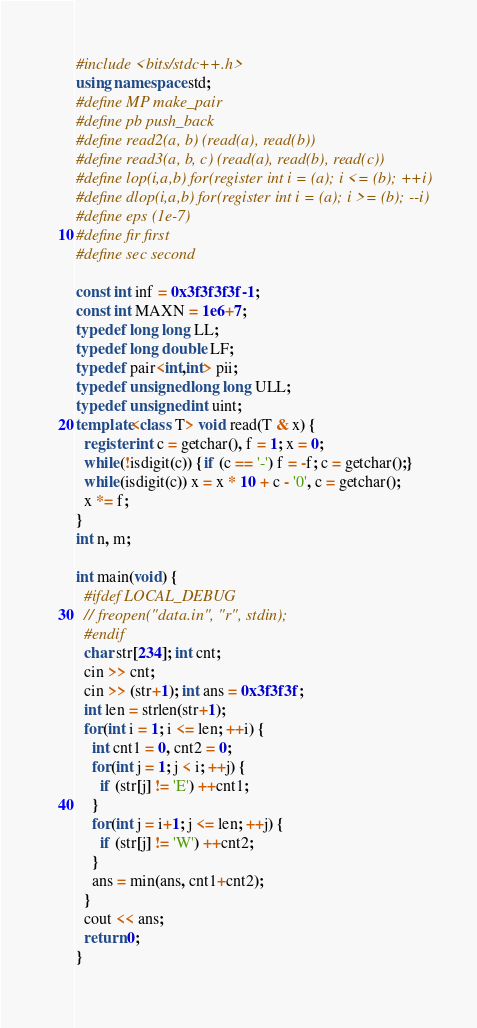<code> <loc_0><loc_0><loc_500><loc_500><_C++_>#include <bits/stdc++.h>
using namespace std;
#define MP make_pair
#define pb push_back
#define read2(a, b) (read(a), read(b))
#define read3(a, b, c) (read(a), read(b), read(c))
#define lop(i,a,b) for(register int i = (a); i <= (b); ++i)
#define dlop(i,a,b) for(register int i = (a); i >= (b); --i)
#define eps (1e-7)
#define fir first
#define sec second

const int inf = 0x3f3f3f3f-1;
const int MAXN = 1e6+7;
typedef long long LL;
typedef long double LF;
typedef pair<int,int> pii;
typedef unsigned long long ULL;
typedef unsigned int uint;
template<class T> void read(T & x) {
  register int c = getchar(), f = 1; x = 0;
  while(!isdigit(c)) {if (c == '-') f = -f; c = getchar();}
  while(isdigit(c)) x = x * 10 + c - '0', c = getchar();
  x *= f;
}
int n, m;

int main(void) {
  #ifdef LOCAL_DEBUG
  // freopen("data.in", "r", stdin);
  #endif
  char str[234]; int cnt;
  cin >> cnt;
  cin >> (str+1); int ans = 0x3f3f3f;
  int len = strlen(str+1);
  for(int i = 1; i <= len; ++i) {
    int cnt1 = 0, cnt2 = 0;
    for(int j = 1; j < i; ++j) {
      if (str[j] != 'E') ++cnt1;
    }
    for(int j = i+1; j <= len; ++j) {
      if (str[j] != 'W') ++cnt2;
    }
    ans = min(ans, cnt1+cnt2);
  }
  cout << ans;
  return 0;
}</code> 